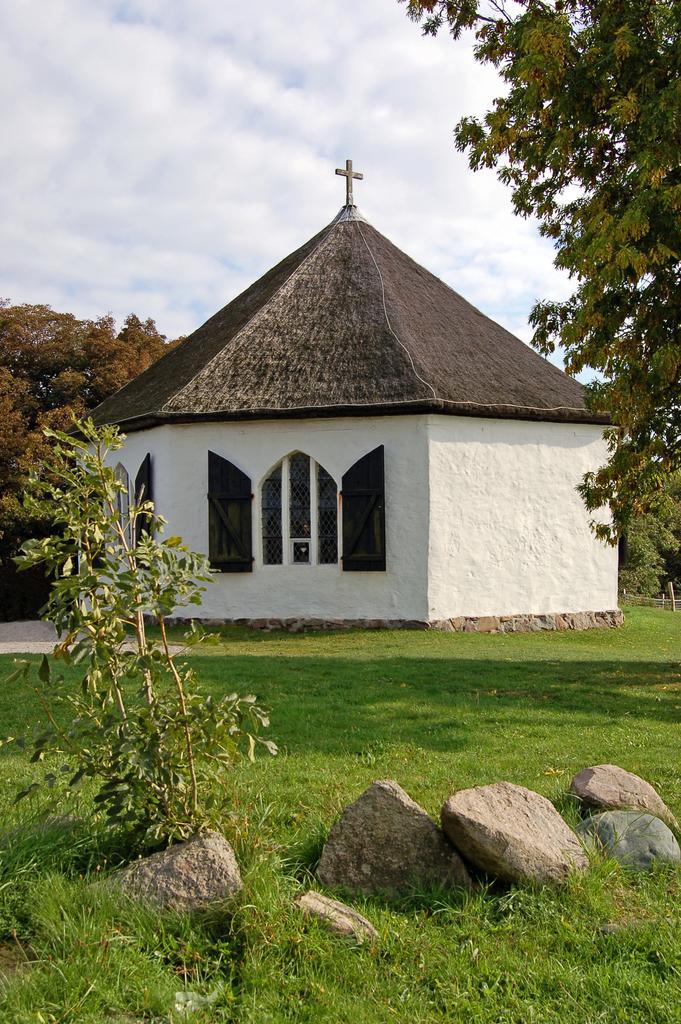How would you summarize this image in a sentence or two? In this image I see a building over here and I see the green grass and I see few stones over here and I see few plants. In the background I see the trees and the sky. 